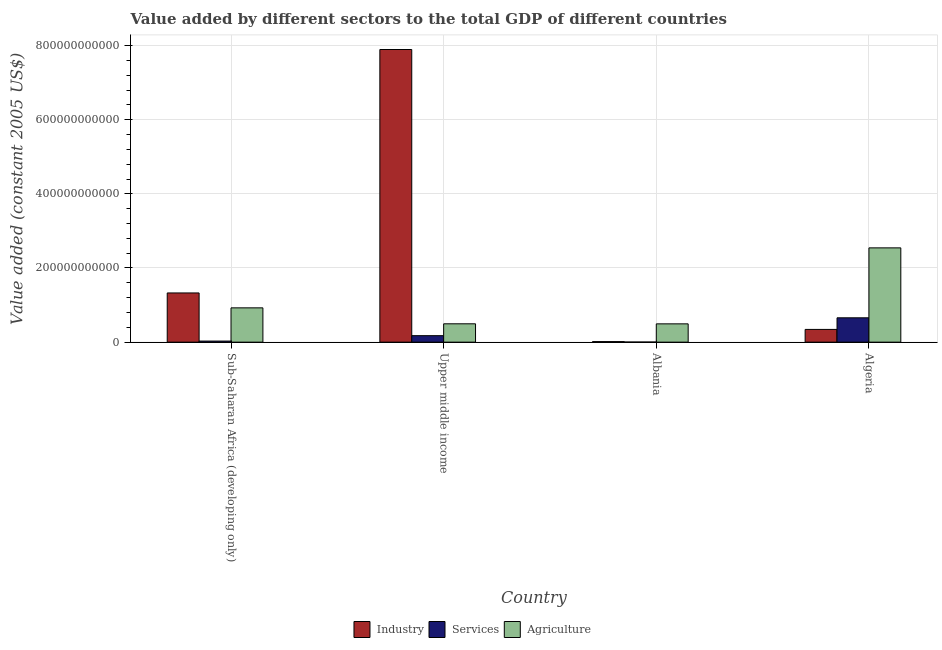How many different coloured bars are there?
Make the answer very short. 3. How many bars are there on the 1st tick from the left?
Keep it short and to the point. 3. What is the label of the 3rd group of bars from the left?
Offer a very short reply. Albania. What is the value added by agricultural sector in Sub-Saharan Africa (developing only)?
Keep it short and to the point. 9.25e+1. Across all countries, what is the maximum value added by industrial sector?
Keep it short and to the point. 7.89e+11. Across all countries, what is the minimum value added by services?
Make the answer very short. 2.56e+08. In which country was the value added by agricultural sector maximum?
Your answer should be compact. Algeria. In which country was the value added by industrial sector minimum?
Your answer should be compact. Albania. What is the total value added by services in the graph?
Give a very brief answer. 8.63e+1. What is the difference between the value added by agricultural sector in Algeria and that in Upper middle income?
Offer a very short reply. 2.05e+11. What is the difference between the value added by services in Algeria and the value added by industrial sector in Albania?
Your answer should be compact. 6.42e+1. What is the average value added by industrial sector per country?
Keep it short and to the point. 2.39e+11. What is the difference between the value added by industrial sector and value added by agricultural sector in Algeria?
Give a very brief answer. -2.20e+11. In how many countries, is the value added by industrial sector greater than 320000000000 US$?
Keep it short and to the point. 1. What is the ratio of the value added by industrial sector in Albania to that in Sub-Saharan Africa (developing only)?
Provide a succinct answer. 0.01. Is the value added by industrial sector in Algeria less than that in Sub-Saharan Africa (developing only)?
Make the answer very short. Yes. Is the difference between the value added by industrial sector in Albania and Upper middle income greater than the difference between the value added by services in Albania and Upper middle income?
Your response must be concise. No. What is the difference between the highest and the second highest value added by industrial sector?
Provide a short and direct response. 6.57e+11. What is the difference between the highest and the lowest value added by services?
Your response must be concise. 6.54e+1. In how many countries, is the value added by industrial sector greater than the average value added by industrial sector taken over all countries?
Provide a succinct answer. 1. What does the 1st bar from the left in Albania represents?
Your answer should be very brief. Industry. What does the 3rd bar from the right in Sub-Saharan Africa (developing only) represents?
Your response must be concise. Industry. Is it the case that in every country, the sum of the value added by industrial sector and value added by services is greater than the value added by agricultural sector?
Offer a terse response. No. Are all the bars in the graph horizontal?
Your answer should be very brief. No. What is the difference between two consecutive major ticks on the Y-axis?
Offer a very short reply. 2.00e+11. Does the graph contain any zero values?
Provide a short and direct response. No. How are the legend labels stacked?
Ensure brevity in your answer.  Horizontal. What is the title of the graph?
Your answer should be compact. Value added by different sectors to the total GDP of different countries. Does "Slovak Republic" appear as one of the legend labels in the graph?
Give a very brief answer. No. What is the label or title of the Y-axis?
Offer a very short reply. Value added (constant 2005 US$). What is the Value added (constant 2005 US$) of Industry in Sub-Saharan Africa (developing only)?
Give a very brief answer. 1.33e+11. What is the Value added (constant 2005 US$) in Services in Sub-Saharan Africa (developing only)?
Offer a terse response. 2.92e+09. What is the Value added (constant 2005 US$) in Agriculture in Sub-Saharan Africa (developing only)?
Your response must be concise. 9.25e+1. What is the Value added (constant 2005 US$) in Industry in Upper middle income?
Your response must be concise. 7.89e+11. What is the Value added (constant 2005 US$) of Services in Upper middle income?
Provide a short and direct response. 1.75e+1. What is the Value added (constant 2005 US$) in Agriculture in Upper middle income?
Your answer should be compact. 4.95e+1. What is the Value added (constant 2005 US$) in Industry in Albania?
Provide a short and direct response. 1.46e+09. What is the Value added (constant 2005 US$) of Services in Albania?
Keep it short and to the point. 2.56e+08. What is the Value added (constant 2005 US$) of Agriculture in Albania?
Ensure brevity in your answer.  4.94e+1. What is the Value added (constant 2005 US$) in Industry in Algeria?
Offer a very short reply. 3.43e+1. What is the Value added (constant 2005 US$) in Services in Algeria?
Offer a terse response. 6.57e+1. What is the Value added (constant 2005 US$) of Agriculture in Algeria?
Make the answer very short. 2.54e+11. Across all countries, what is the maximum Value added (constant 2005 US$) of Industry?
Ensure brevity in your answer.  7.89e+11. Across all countries, what is the maximum Value added (constant 2005 US$) of Services?
Provide a short and direct response. 6.57e+1. Across all countries, what is the maximum Value added (constant 2005 US$) of Agriculture?
Give a very brief answer. 2.54e+11. Across all countries, what is the minimum Value added (constant 2005 US$) of Industry?
Provide a short and direct response. 1.46e+09. Across all countries, what is the minimum Value added (constant 2005 US$) in Services?
Provide a short and direct response. 2.56e+08. Across all countries, what is the minimum Value added (constant 2005 US$) in Agriculture?
Your response must be concise. 4.94e+1. What is the total Value added (constant 2005 US$) in Industry in the graph?
Give a very brief answer. 9.58e+11. What is the total Value added (constant 2005 US$) in Services in the graph?
Make the answer very short. 8.63e+1. What is the total Value added (constant 2005 US$) of Agriculture in the graph?
Offer a terse response. 4.46e+11. What is the difference between the Value added (constant 2005 US$) in Industry in Sub-Saharan Africa (developing only) and that in Upper middle income?
Your response must be concise. -6.57e+11. What is the difference between the Value added (constant 2005 US$) of Services in Sub-Saharan Africa (developing only) and that in Upper middle income?
Provide a short and direct response. -1.46e+1. What is the difference between the Value added (constant 2005 US$) in Agriculture in Sub-Saharan Africa (developing only) and that in Upper middle income?
Your answer should be very brief. 4.30e+1. What is the difference between the Value added (constant 2005 US$) in Industry in Sub-Saharan Africa (developing only) and that in Albania?
Provide a short and direct response. 1.31e+11. What is the difference between the Value added (constant 2005 US$) of Services in Sub-Saharan Africa (developing only) and that in Albania?
Your answer should be compact. 2.66e+09. What is the difference between the Value added (constant 2005 US$) in Agriculture in Sub-Saharan Africa (developing only) and that in Albania?
Give a very brief answer. 4.31e+1. What is the difference between the Value added (constant 2005 US$) of Industry in Sub-Saharan Africa (developing only) and that in Algeria?
Keep it short and to the point. 9.84e+1. What is the difference between the Value added (constant 2005 US$) of Services in Sub-Saharan Africa (developing only) and that in Algeria?
Provide a succinct answer. -6.27e+1. What is the difference between the Value added (constant 2005 US$) of Agriculture in Sub-Saharan Africa (developing only) and that in Algeria?
Your answer should be very brief. -1.62e+11. What is the difference between the Value added (constant 2005 US$) of Industry in Upper middle income and that in Albania?
Give a very brief answer. 7.88e+11. What is the difference between the Value added (constant 2005 US$) in Services in Upper middle income and that in Albania?
Offer a very short reply. 1.72e+1. What is the difference between the Value added (constant 2005 US$) in Agriculture in Upper middle income and that in Albania?
Offer a very short reply. 1.26e+08. What is the difference between the Value added (constant 2005 US$) in Industry in Upper middle income and that in Algeria?
Ensure brevity in your answer.  7.55e+11. What is the difference between the Value added (constant 2005 US$) of Services in Upper middle income and that in Algeria?
Offer a terse response. -4.82e+1. What is the difference between the Value added (constant 2005 US$) in Agriculture in Upper middle income and that in Algeria?
Offer a very short reply. -2.05e+11. What is the difference between the Value added (constant 2005 US$) in Industry in Albania and that in Algeria?
Provide a short and direct response. -3.29e+1. What is the difference between the Value added (constant 2005 US$) of Services in Albania and that in Algeria?
Your answer should be very brief. -6.54e+1. What is the difference between the Value added (constant 2005 US$) in Agriculture in Albania and that in Algeria?
Provide a short and direct response. -2.05e+11. What is the difference between the Value added (constant 2005 US$) in Industry in Sub-Saharan Africa (developing only) and the Value added (constant 2005 US$) in Services in Upper middle income?
Your response must be concise. 1.15e+11. What is the difference between the Value added (constant 2005 US$) of Industry in Sub-Saharan Africa (developing only) and the Value added (constant 2005 US$) of Agriculture in Upper middle income?
Give a very brief answer. 8.32e+1. What is the difference between the Value added (constant 2005 US$) of Services in Sub-Saharan Africa (developing only) and the Value added (constant 2005 US$) of Agriculture in Upper middle income?
Make the answer very short. -4.66e+1. What is the difference between the Value added (constant 2005 US$) of Industry in Sub-Saharan Africa (developing only) and the Value added (constant 2005 US$) of Services in Albania?
Provide a succinct answer. 1.32e+11. What is the difference between the Value added (constant 2005 US$) in Industry in Sub-Saharan Africa (developing only) and the Value added (constant 2005 US$) in Agriculture in Albania?
Ensure brevity in your answer.  8.33e+1. What is the difference between the Value added (constant 2005 US$) in Services in Sub-Saharan Africa (developing only) and the Value added (constant 2005 US$) in Agriculture in Albania?
Your answer should be compact. -4.64e+1. What is the difference between the Value added (constant 2005 US$) in Industry in Sub-Saharan Africa (developing only) and the Value added (constant 2005 US$) in Services in Algeria?
Keep it short and to the point. 6.70e+1. What is the difference between the Value added (constant 2005 US$) of Industry in Sub-Saharan Africa (developing only) and the Value added (constant 2005 US$) of Agriculture in Algeria?
Offer a terse response. -1.22e+11. What is the difference between the Value added (constant 2005 US$) in Services in Sub-Saharan Africa (developing only) and the Value added (constant 2005 US$) in Agriculture in Algeria?
Offer a terse response. -2.51e+11. What is the difference between the Value added (constant 2005 US$) of Industry in Upper middle income and the Value added (constant 2005 US$) of Services in Albania?
Make the answer very short. 7.89e+11. What is the difference between the Value added (constant 2005 US$) of Industry in Upper middle income and the Value added (constant 2005 US$) of Agriculture in Albania?
Provide a succinct answer. 7.40e+11. What is the difference between the Value added (constant 2005 US$) of Services in Upper middle income and the Value added (constant 2005 US$) of Agriculture in Albania?
Your answer should be very brief. -3.19e+1. What is the difference between the Value added (constant 2005 US$) of Industry in Upper middle income and the Value added (constant 2005 US$) of Services in Algeria?
Provide a succinct answer. 7.24e+11. What is the difference between the Value added (constant 2005 US$) in Industry in Upper middle income and the Value added (constant 2005 US$) in Agriculture in Algeria?
Your answer should be compact. 5.35e+11. What is the difference between the Value added (constant 2005 US$) of Services in Upper middle income and the Value added (constant 2005 US$) of Agriculture in Algeria?
Offer a very short reply. -2.37e+11. What is the difference between the Value added (constant 2005 US$) of Industry in Albania and the Value added (constant 2005 US$) of Services in Algeria?
Your answer should be compact. -6.42e+1. What is the difference between the Value added (constant 2005 US$) of Industry in Albania and the Value added (constant 2005 US$) of Agriculture in Algeria?
Ensure brevity in your answer.  -2.53e+11. What is the difference between the Value added (constant 2005 US$) in Services in Albania and the Value added (constant 2005 US$) in Agriculture in Algeria?
Your response must be concise. -2.54e+11. What is the average Value added (constant 2005 US$) of Industry per country?
Keep it short and to the point. 2.39e+11. What is the average Value added (constant 2005 US$) in Services per country?
Your answer should be very brief. 2.16e+1. What is the average Value added (constant 2005 US$) of Agriculture per country?
Provide a succinct answer. 1.11e+11. What is the difference between the Value added (constant 2005 US$) of Industry and Value added (constant 2005 US$) of Services in Sub-Saharan Africa (developing only)?
Your answer should be very brief. 1.30e+11. What is the difference between the Value added (constant 2005 US$) in Industry and Value added (constant 2005 US$) in Agriculture in Sub-Saharan Africa (developing only)?
Give a very brief answer. 4.02e+1. What is the difference between the Value added (constant 2005 US$) of Services and Value added (constant 2005 US$) of Agriculture in Sub-Saharan Africa (developing only)?
Your response must be concise. -8.96e+1. What is the difference between the Value added (constant 2005 US$) in Industry and Value added (constant 2005 US$) in Services in Upper middle income?
Provide a succinct answer. 7.72e+11. What is the difference between the Value added (constant 2005 US$) of Industry and Value added (constant 2005 US$) of Agriculture in Upper middle income?
Offer a terse response. 7.40e+11. What is the difference between the Value added (constant 2005 US$) of Services and Value added (constant 2005 US$) of Agriculture in Upper middle income?
Give a very brief answer. -3.20e+1. What is the difference between the Value added (constant 2005 US$) of Industry and Value added (constant 2005 US$) of Services in Albania?
Your answer should be compact. 1.20e+09. What is the difference between the Value added (constant 2005 US$) of Industry and Value added (constant 2005 US$) of Agriculture in Albania?
Your answer should be very brief. -4.79e+1. What is the difference between the Value added (constant 2005 US$) in Services and Value added (constant 2005 US$) in Agriculture in Albania?
Provide a short and direct response. -4.91e+1. What is the difference between the Value added (constant 2005 US$) of Industry and Value added (constant 2005 US$) of Services in Algeria?
Keep it short and to the point. -3.13e+1. What is the difference between the Value added (constant 2005 US$) in Industry and Value added (constant 2005 US$) in Agriculture in Algeria?
Provide a succinct answer. -2.20e+11. What is the difference between the Value added (constant 2005 US$) of Services and Value added (constant 2005 US$) of Agriculture in Algeria?
Your response must be concise. -1.89e+11. What is the ratio of the Value added (constant 2005 US$) in Industry in Sub-Saharan Africa (developing only) to that in Upper middle income?
Offer a very short reply. 0.17. What is the ratio of the Value added (constant 2005 US$) of Services in Sub-Saharan Africa (developing only) to that in Upper middle income?
Your answer should be compact. 0.17. What is the ratio of the Value added (constant 2005 US$) of Agriculture in Sub-Saharan Africa (developing only) to that in Upper middle income?
Your response must be concise. 1.87. What is the ratio of the Value added (constant 2005 US$) of Industry in Sub-Saharan Africa (developing only) to that in Albania?
Your answer should be compact. 91.15. What is the ratio of the Value added (constant 2005 US$) in Services in Sub-Saharan Africa (developing only) to that in Albania?
Ensure brevity in your answer.  11.4. What is the ratio of the Value added (constant 2005 US$) in Agriculture in Sub-Saharan Africa (developing only) to that in Albania?
Your response must be concise. 1.87. What is the ratio of the Value added (constant 2005 US$) of Industry in Sub-Saharan Africa (developing only) to that in Algeria?
Your response must be concise. 3.86. What is the ratio of the Value added (constant 2005 US$) in Services in Sub-Saharan Africa (developing only) to that in Algeria?
Your response must be concise. 0.04. What is the ratio of the Value added (constant 2005 US$) of Agriculture in Sub-Saharan Africa (developing only) to that in Algeria?
Your response must be concise. 0.36. What is the ratio of the Value added (constant 2005 US$) in Industry in Upper middle income to that in Albania?
Your answer should be very brief. 542.16. What is the ratio of the Value added (constant 2005 US$) of Services in Upper middle income to that in Albania?
Your response must be concise. 68.39. What is the ratio of the Value added (constant 2005 US$) in Industry in Upper middle income to that in Algeria?
Offer a terse response. 22.98. What is the ratio of the Value added (constant 2005 US$) in Services in Upper middle income to that in Algeria?
Provide a short and direct response. 0.27. What is the ratio of the Value added (constant 2005 US$) in Agriculture in Upper middle income to that in Algeria?
Offer a terse response. 0.19. What is the ratio of the Value added (constant 2005 US$) of Industry in Albania to that in Algeria?
Your answer should be very brief. 0.04. What is the ratio of the Value added (constant 2005 US$) in Services in Albania to that in Algeria?
Offer a very short reply. 0. What is the ratio of the Value added (constant 2005 US$) in Agriculture in Albania to that in Algeria?
Make the answer very short. 0.19. What is the difference between the highest and the second highest Value added (constant 2005 US$) in Industry?
Offer a terse response. 6.57e+11. What is the difference between the highest and the second highest Value added (constant 2005 US$) in Services?
Make the answer very short. 4.82e+1. What is the difference between the highest and the second highest Value added (constant 2005 US$) of Agriculture?
Offer a terse response. 1.62e+11. What is the difference between the highest and the lowest Value added (constant 2005 US$) in Industry?
Keep it short and to the point. 7.88e+11. What is the difference between the highest and the lowest Value added (constant 2005 US$) in Services?
Offer a terse response. 6.54e+1. What is the difference between the highest and the lowest Value added (constant 2005 US$) of Agriculture?
Provide a succinct answer. 2.05e+11. 